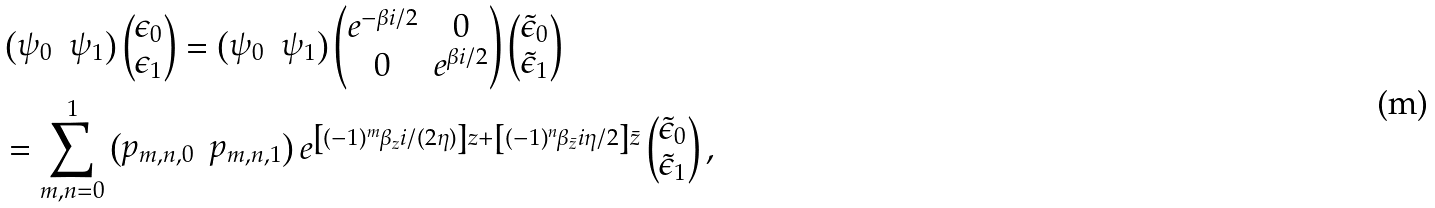Convert formula to latex. <formula><loc_0><loc_0><loc_500><loc_500>& \begin{pmatrix} \psi _ { 0 } & \psi _ { 1 } \end{pmatrix} \begin{pmatrix} \epsilon _ { 0 } \\ \epsilon _ { 1 } \end{pmatrix} = \begin{pmatrix} \psi _ { 0 } & \psi _ { 1 } \end{pmatrix} \begin{pmatrix} e ^ { - \beta i / 2 } & 0 \\ 0 & e ^ { \beta i / 2 } \end{pmatrix} \begin{pmatrix} \tilde { \epsilon } _ { 0 } \\ \tilde { \epsilon } _ { 1 } \end{pmatrix} \\ & = \sum _ { m , n = 0 } ^ { 1 } \begin{pmatrix} p _ { m , n , 0 } & p _ { m , n , 1 } \end{pmatrix} e ^ { \left [ ( - 1 ) ^ { m } \beta _ { z } i / ( 2 \eta ) \right ] z + \left [ ( - 1 ) ^ { n } \beta _ { \bar { z } } i \eta / 2 \right ] \bar { z } } \begin{pmatrix} \tilde { \epsilon } _ { 0 } \\ \tilde { \epsilon } _ { 1 } \end{pmatrix} ,</formula> 